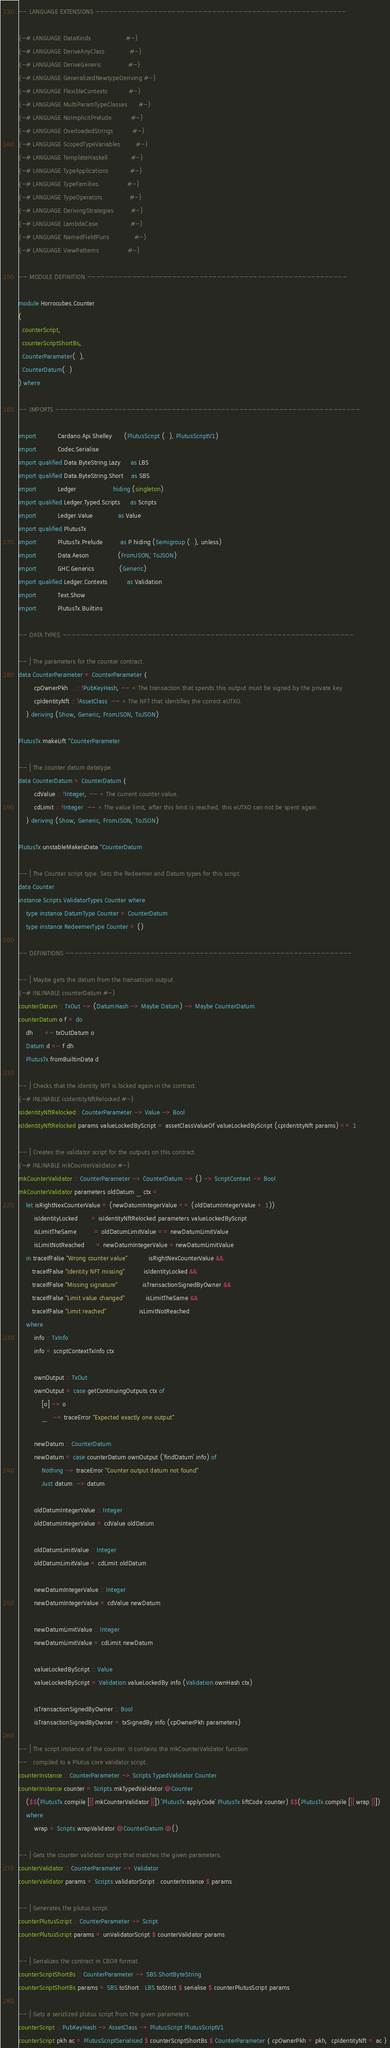<code> <loc_0><loc_0><loc_500><loc_500><_Haskell_>
-- LANGUAGE EXTENSIONS --------------------------------------------------------

{-# LANGUAGE DataKinds                  #-}
{-# LANGUAGE DeriveAnyClass             #-}
{-# LANGUAGE DeriveGeneric              #-}
{-# LANGUAGE GeneralizedNewtypeDeriving #-}
{-# LANGUAGE FlexibleContexts           #-}
{-# LANGUAGE MultiParamTypeClasses      #-}
{-# LANGUAGE NoImplicitPrelude          #-}
{-# LANGUAGE OverloadedStrings          #-}
{-# LANGUAGE ScopedTypeVariables        #-}
{-# LANGUAGE TemplateHaskell            #-}
{-# LANGUAGE TypeApplications           #-}
{-# LANGUAGE TypeFamilies               #-}
{-# LANGUAGE TypeOperators              #-}
{-# LANGUAGE DerivingStrategies         #-}
{-# LANGUAGE LambdaCase                 #-}
{-# LANGUAGE NamedFieldPuns             #-}
{-# LANGUAGE ViewPatterns               #-}

-- MODULE DEFINITION ----------------------------------------------------------

module Horrocubes.Counter
(
  counterScript,
  counterScriptShortBs,
  CounterParameter(..),
  CounterDatum(..)
) where

-- IMPORTS --------------------------------------------------------------------

import           Cardano.Api.Shelley      (PlutusScript (..), PlutusScriptV1)
import           Codec.Serialise
import qualified Data.ByteString.Lazy     as LBS
import qualified Data.ByteString.Short    as SBS
import           Ledger                   hiding (singleton)
import qualified Ledger.Typed.Scripts     as Scripts
import           Ledger.Value             as Value
import qualified PlutusTx
import           PlutusTx.Prelude         as P hiding (Semigroup (..), unless)
import           Data.Aeson               (FromJSON, ToJSON)
import           GHC.Generics             (Generic)
import qualified Ledger.Contexts          as Validation
import           Text.Show
import           PlutusTx.Builtins

-- DATA TYPES -----------------------------------------------------------------

-- | The parameters for the counter contract.
data CounterParameter = CounterParameter {
        cpOwnerPkh    :: !PubKeyHash, -- ^ The transaction that spends this output must be signed by the private key
        cpIdentityNft :: !AssetClass  -- ^ The NFT that identifies the correct eUTXO.
    } deriving (Show, Generic, FromJSON, ToJSON)

PlutusTx.makeLift ''CounterParameter

-- | The counter datum datatype.
data CounterDatum = CounterDatum {
        cdValue :: !Integer, -- ^ The current counter value.
        cdLimit :: !Integer  -- ^ The value limit, after this limit is reached, this eUTXO can not be spent again.
    } deriving (Show, Generic, FromJSON, ToJSON)

PlutusTx.unstableMakeIsData ''CounterDatum

-- | The Counter script type. Sets the Redeemer and Datum types for this script.
data Counter 
instance Scripts.ValidatorTypes Counter where
    type instance DatumType Counter = CounterDatum
    type instance RedeemerType Counter = ()
    
-- DEFINITIONS ----------------------------------------------------------------

-- | Maybe gets the datum from the transatcion output.
{-# INLINABLE counterDatum #-}
counterDatum :: TxOut -> (DatumHash -> Maybe Datum) -> Maybe CounterDatum
counterDatum o f = do
    dh      <- txOutDatum o
    Datum d <- f dh
    PlutusTx.fromBuiltinData d

-- | Checks that the identity NFT is locked again in the contract.
{-# INLINABLE isIdentityNftRelocked #-}
isIdentityNftRelocked:: CounterParameter -> Value -> Bool
isIdentityNftRelocked params valueLockedByScript = assetClassValueOf valueLockedByScript (cpIdentityNft params) == 1

-- | Creates the validator script for the outputs on this contract.
{-# INLINABLE mkCounterValidator #-}
mkCounterValidator :: CounterParameter -> CounterDatum -> () -> ScriptContext -> Bool
mkCounterValidator parameters oldDatum _ ctx = 
    let isRightNexCounterValue = (newDatumIntegerValue == (oldDatumIntegerValue + 1))
        isIdentityLocked       = isIdentityNftRelocked parameters valueLockedByScript
        isLimitTheSame         = oldDatumLimitValue == newDatumLimitValue
        isLimitNotReached      = newDatumIntegerValue < newDatumLimitValue
    in traceIfFalse "Wrong counter value"           isRightNexCounterValue && 
       traceIfFalse "Identity NFT missing"          isIdentityLocked && 
       traceIfFalse "Missing signature"             isTransactionSignedByOwner &&
       traceIfFalse "Limit value changed"           isLimitTheSame &&
       traceIfFalse "Limit reached"                 isLimitNotReached
    where
        info :: TxInfo
        info = scriptContextTxInfo ctx

        ownOutput :: TxOut
        ownOutput = case getContinuingOutputs ctx of
            [o] -> o
            _   -> traceError "Expected exactly one output"

        newDatum :: CounterDatum
        newDatum = case counterDatum ownOutput (`findDatum` info) of
            Nothing -> traceError "Counter output datum not found"
            Just datum  -> datum

        oldDatumIntegerValue :: Integer
        oldDatumIntegerValue = cdValue oldDatum

        oldDatumLimitValue :: Integer
        oldDatumLimitValue = cdLimit oldDatum

        newDatumIntegerValue :: Integer
        newDatumIntegerValue = cdValue newDatum

        newDatumLimitValue :: Integer
        newDatumLimitValue = cdLimit newDatum

        valueLockedByScript :: Value
        valueLockedByScript = Validation.valueLockedBy info (Validation.ownHash ctx)

        isTransactionSignedByOwner :: Bool
        isTransactionSignedByOwner = txSignedBy info (cpOwnerPkh parameters)

-- | The script instance of the counter. It contains the mkCounterValidator function
--   compiled to a Plutus core validator script.
counterInstance :: CounterParameter -> Scripts.TypedValidator Counter
counterInstance counter = Scripts.mkTypedValidator @Counter
    ($$(PlutusTx.compile [|| mkCounterValidator ||]) `PlutusTx.applyCode` PlutusTx.liftCode counter) $$(PlutusTx.compile [|| wrap ||])
    where
        wrap = Scripts.wrapValidator @CounterDatum @()

-- | Gets the counter validator script that matches the given parameters.
counterValidator :: CounterParameter -> Validator
counterValidator params = Scripts.validatorScript . counterInstance $ params

-- | Generates the plutus script.
counterPlutusScript :: CounterParameter -> Script
counterPlutusScript params = unValidatorScript $ counterValidator params

-- | Serializes the contract in CBOR format.
counterScriptShortBs :: CounterParameter -> SBS.ShortByteString
counterScriptShortBs params = SBS.toShort . LBS.toStrict $ serialise $ counterPlutusScript params

-- | Gets a serizlized plutus script from the given parameters.
counterScript :: PubKeyHash -> AssetClass -> PlutusScript PlutusScriptV1
counterScript pkh ac = PlutusScriptSerialised $ counterScriptShortBs $ CounterParameter { cpOwnerPkh = pkh,  cpIdentityNft = ac }
</code> 